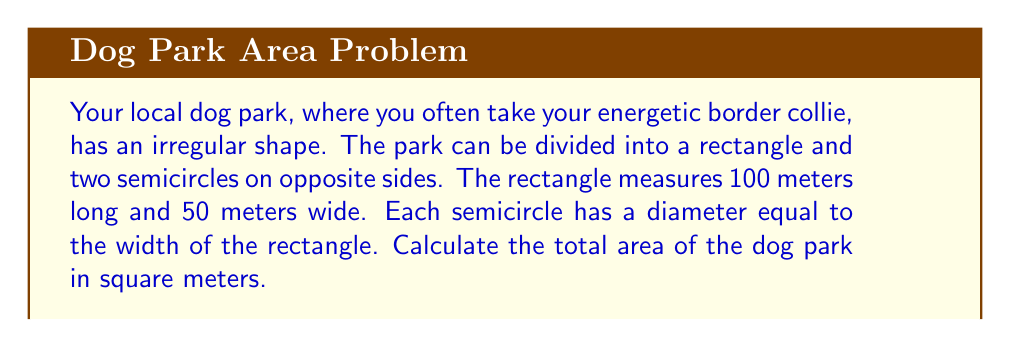Can you answer this question? Let's approach this step-by-step:

1) First, let's calculate the area of the rectangular part:
   $$ A_{rectangle} = length \times width = 100 \text{ m} \times 50 \text{ m} = 5000 \text{ m}^2 $$

2) Now, for the semicircles. The diameter of each semicircle is equal to the width of the rectangle, which is 50 m. So the radius is half of this:
   $$ r = 50 \text{ m} \div 2 = 25 \text{ m} $$

3) The area of a full circle is $\pi r^2$, so the area of a semicircle is half of this:
   $$ A_{semicircle} = \frac{1}{2} \pi r^2 = \frac{1}{2} \pi (25 \text{ m})^2 = \frac{1}{2} \pi \times 625 \text{ m}^2 = 312.5\pi \text{ m}^2 $$

4) There are two semicircles, so we double this:
   $$ A_{two semicircles} = 2 \times 312.5\pi \text{ m}^2 = 625\pi \text{ m}^2 $$

5) The total area is the sum of the rectangle and the two semicircles:
   $$ A_{total} = A_{rectangle} + A_{two semicircles} = 5000 \text{ m}^2 + 625\pi \text{ m}^2 $$

6) Simplifying:
   $$ A_{total} = 5000 + 625\pi \text{ m}^2 \approx 6963.5 \text{ m}^2 $$

[asy]
unitsize(0.05cm);
fill((0,0)--(100,0)--(100,50)--(0,50)--cycle,lightgray);
fill(arc((0,25),25,270,90),lightgray);
fill(arc((100,25),25,90,270),lightgray);
draw((0,0)--(100,0)--(100,50)--(0,50)--cycle);
draw(arc((0,25),25,270,90));
draw(arc((100,25),25,90,270));
label("100 m", (50,0), S);
label("50 m", (100,25), E);
[/asy]
Answer: $5000 + 625\pi \text{ m}^2$ or approximately $6963.5 \text{ m}^2$ 